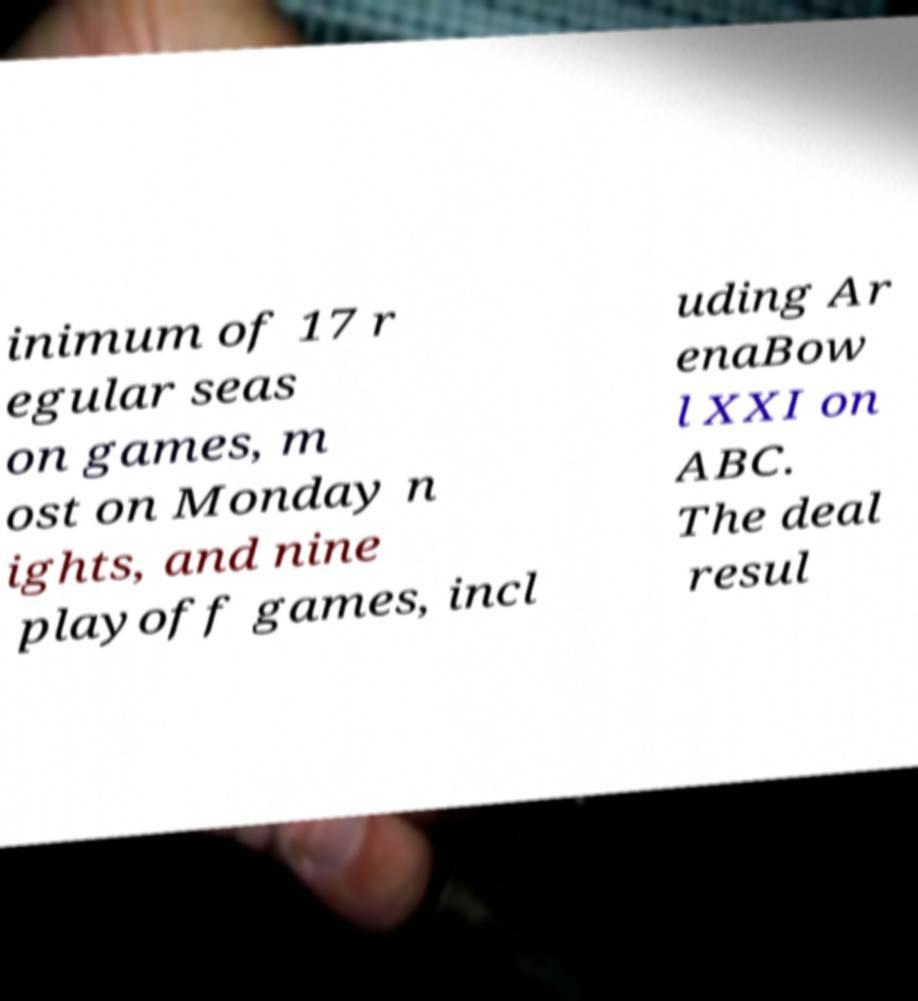Please read and relay the text visible in this image. What does it say? inimum of 17 r egular seas on games, m ost on Monday n ights, and nine playoff games, incl uding Ar enaBow l XXI on ABC. The deal resul 